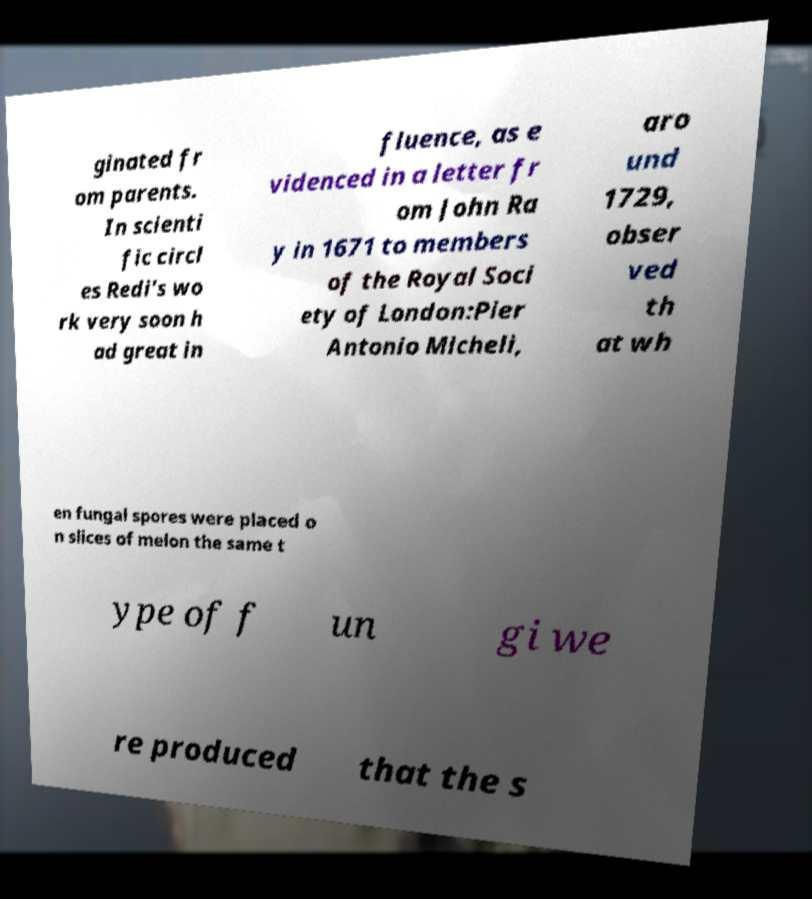Could you extract and type out the text from this image? ginated fr om parents. In scienti fic circl es Redi's wo rk very soon h ad great in fluence, as e videnced in a letter fr om John Ra y in 1671 to members of the Royal Soci ety of London:Pier Antonio Micheli, aro und 1729, obser ved th at wh en fungal spores were placed o n slices of melon the same t ype of f un gi we re produced that the s 